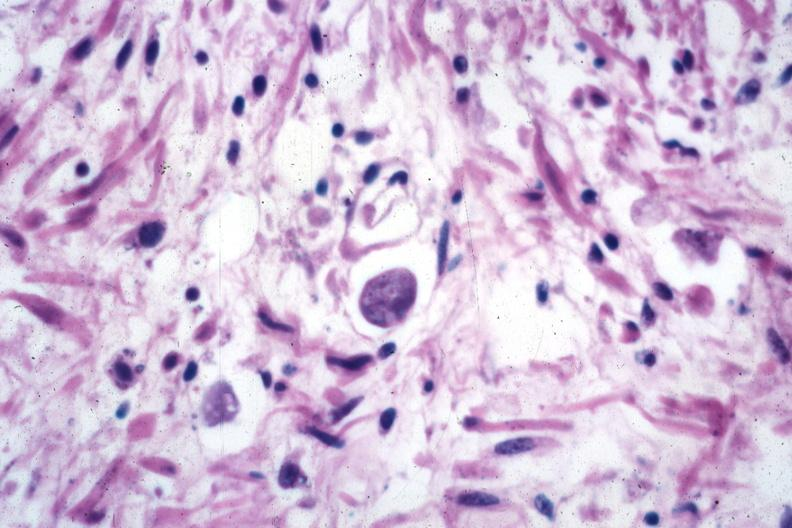s appendix present?
Answer the question using a single word or phrase. No 